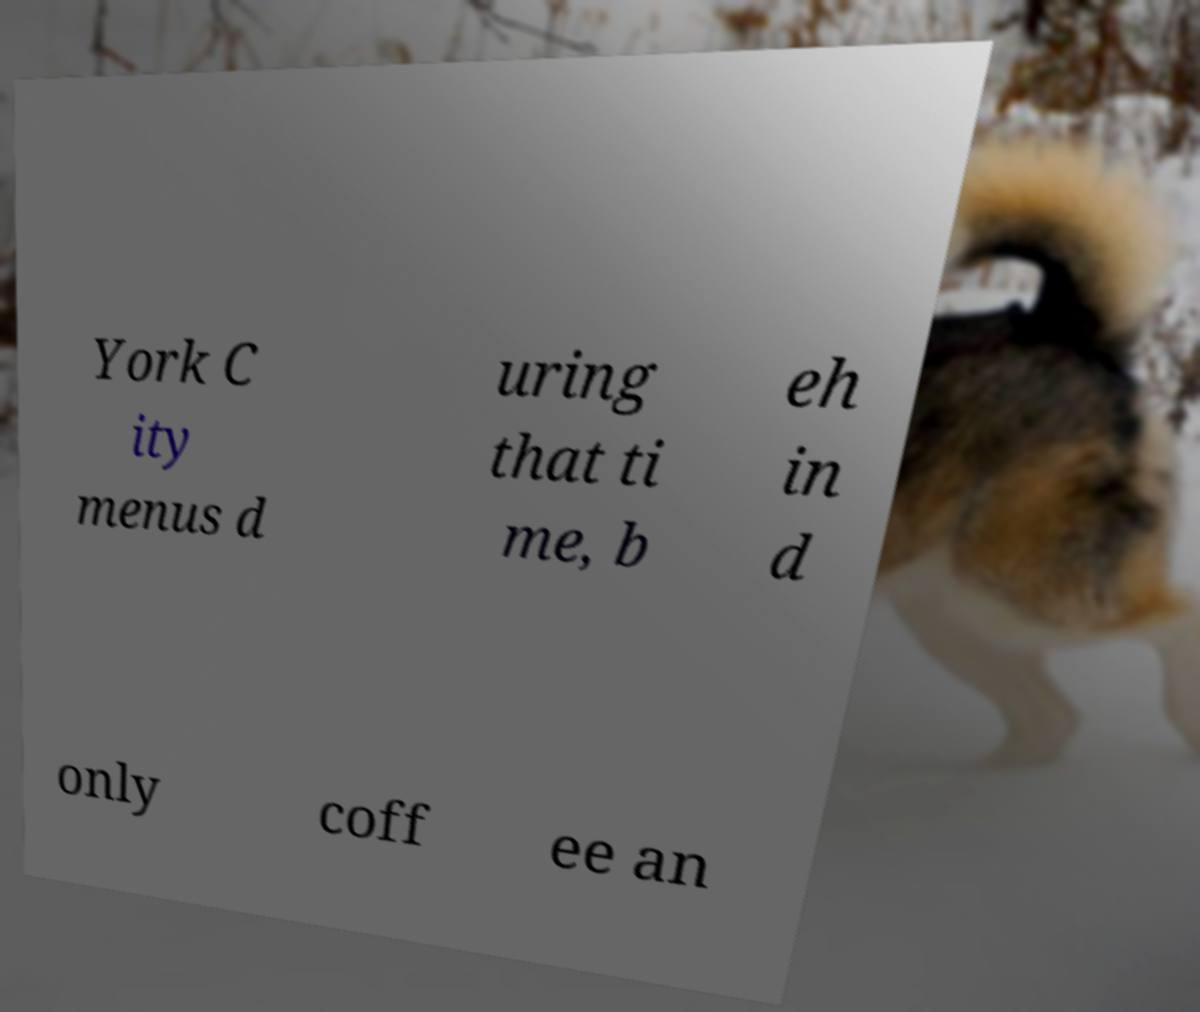Please read and relay the text visible in this image. What does it say? York C ity menus d uring that ti me, b eh in d only coff ee an 